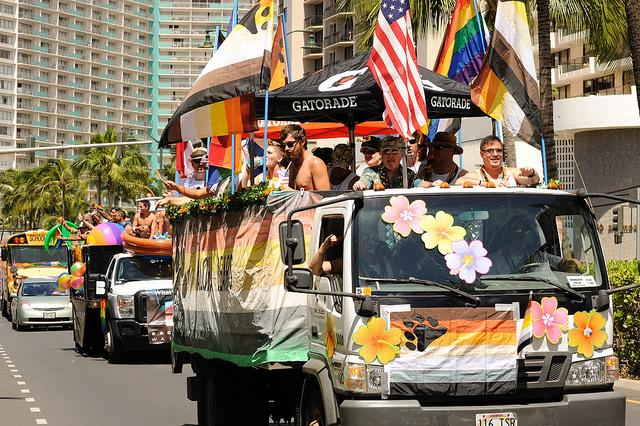Which company manufactures this beverage?

Choices:
A) nestle
B) heineken
C) coca cola
D) pepsico pepsico 